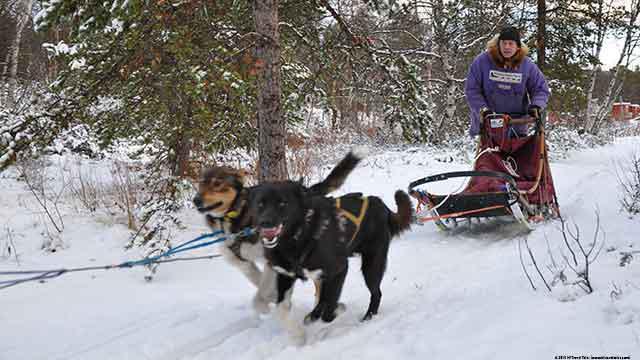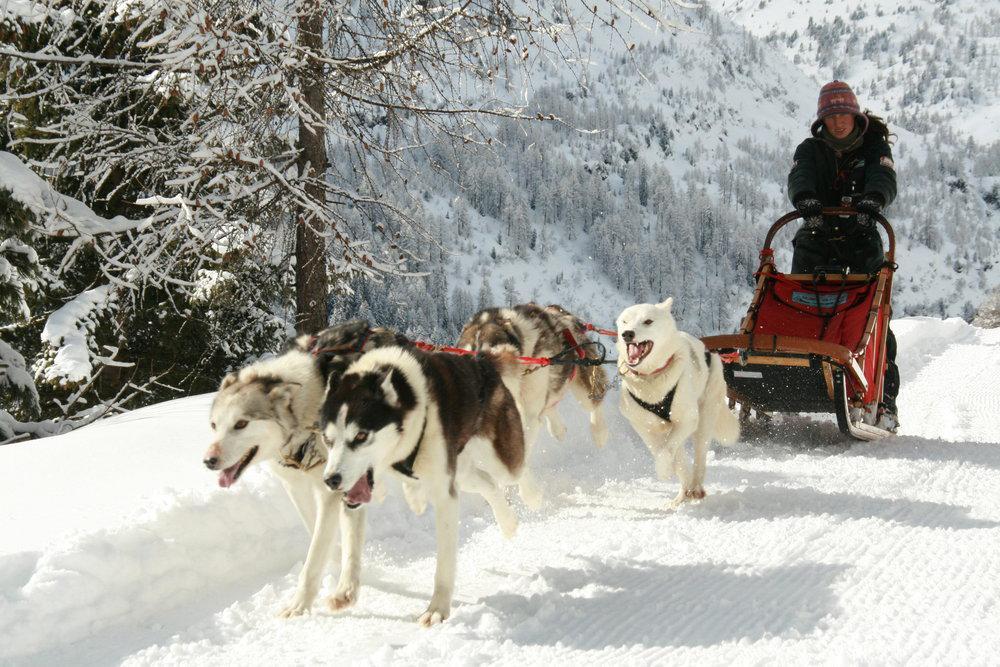The first image is the image on the left, the second image is the image on the right. For the images shown, is this caption "All of the dogs are running in snow." true? Answer yes or no. Yes. The first image is the image on the left, the second image is the image on the right. Considering the images on both sides, is "In the left image, two dogs are pulling a sled on the snow with a rope extending to the left." valid? Answer yes or no. Yes. 